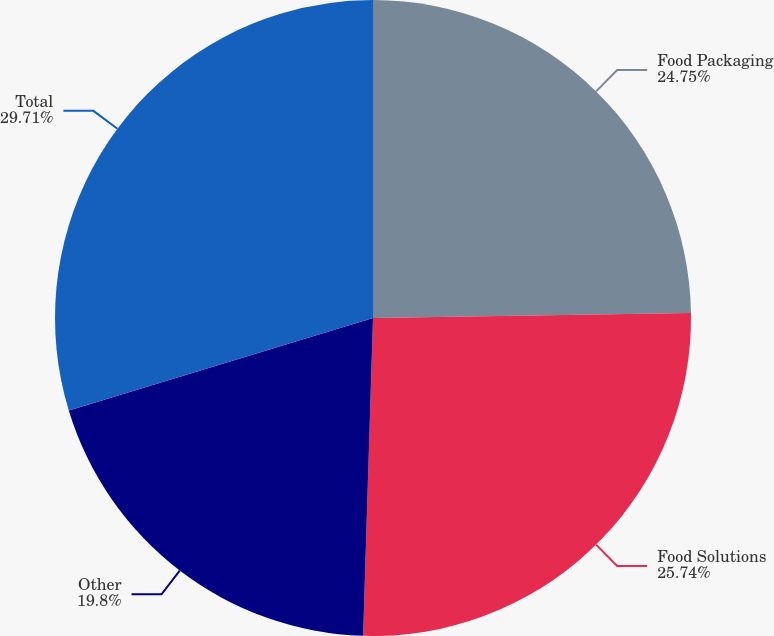Convert chart. <chart><loc_0><loc_0><loc_500><loc_500><pie_chart><fcel>Food Packaging<fcel>Food Solutions<fcel>Other<fcel>Total<nl><fcel>24.75%<fcel>25.74%<fcel>19.8%<fcel>29.7%<nl></chart> 